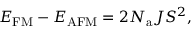Convert formula to latex. <formula><loc_0><loc_0><loc_500><loc_500>E _ { F M } - E _ { A F M } = 2 N _ { a } J S ^ { 2 } ,</formula> 